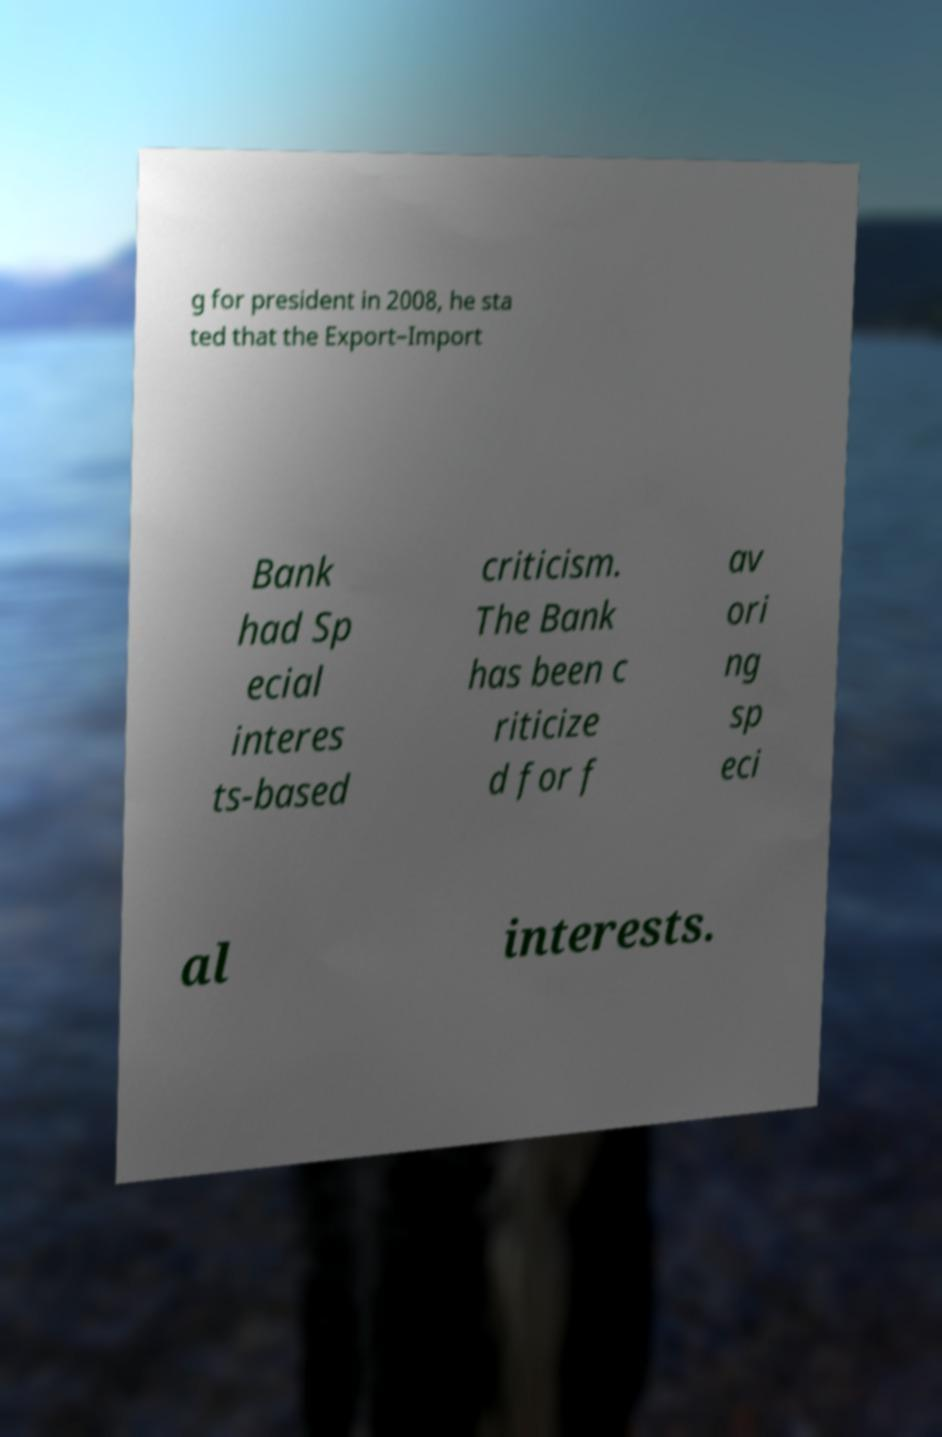I need the written content from this picture converted into text. Can you do that? g for president in 2008, he sta ted that the Export–Import Bank had Sp ecial interes ts-based criticism. The Bank has been c riticize d for f av ori ng sp eci al interests. 